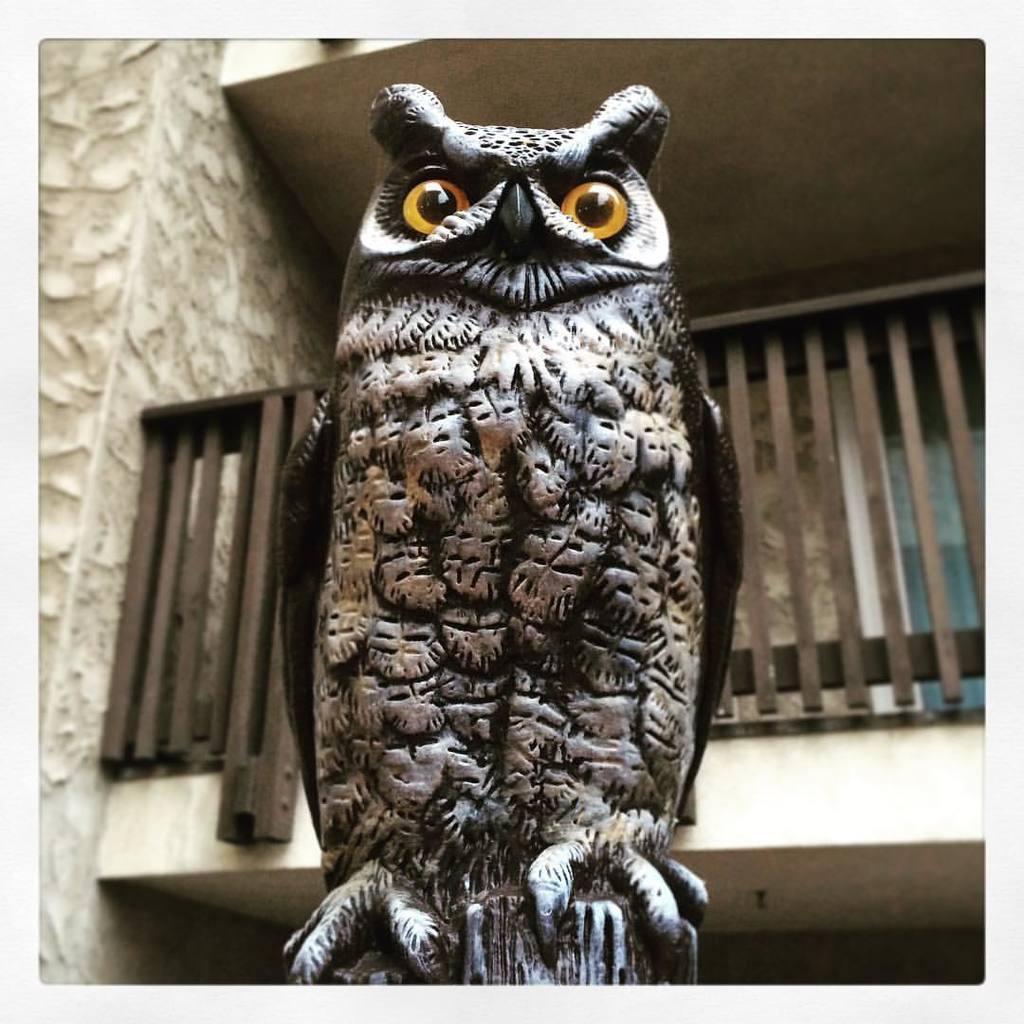Could you give a brief overview of what you see in this image? In this picture we can see the sculpture of an owl. Behind the sculpture, there is a building with a balcony. 